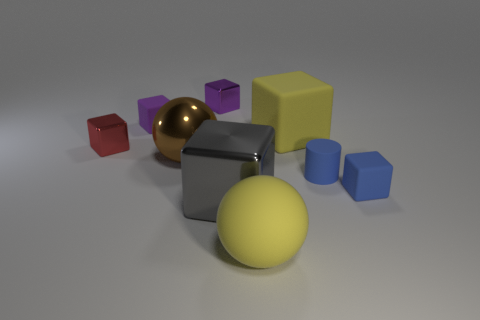What number of rubber objects are yellow cubes or tiny purple cubes?
Provide a short and direct response. 2. There is a tiny cube that is to the right of the shiny object that is behind the red cube; what is its material?
Provide a short and direct response. Rubber. There is a tiny cube that is the same color as the small cylinder; what is its material?
Provide a short and direct response. Rubber. The rubber ball is what color?
Your response must be concise. Yellow. Are there any balls on the right side of the tiny rubber thing that is to the left of the big rubber ball?
Offer a terse response. Yes. What material is the yellow ball?
Give a very brief answer. Rubber. Does the big yellow thing in front of the tiny rubber cylinder have the same material as the big yellow thing that is behind the red metal cube?
Your answer should be compact. Yes. Is there anything else of the same color as the metal sphere?
Give a very brief answer. No. There is a large rubber thing that is the same shape as the small red shiny thing; what is its color?
Make the answer very short. Yellow. How big is the cube that is both in front of the tiny purple rubber object and to the left of the small purple metal object?
Your response must be concise. Small. 